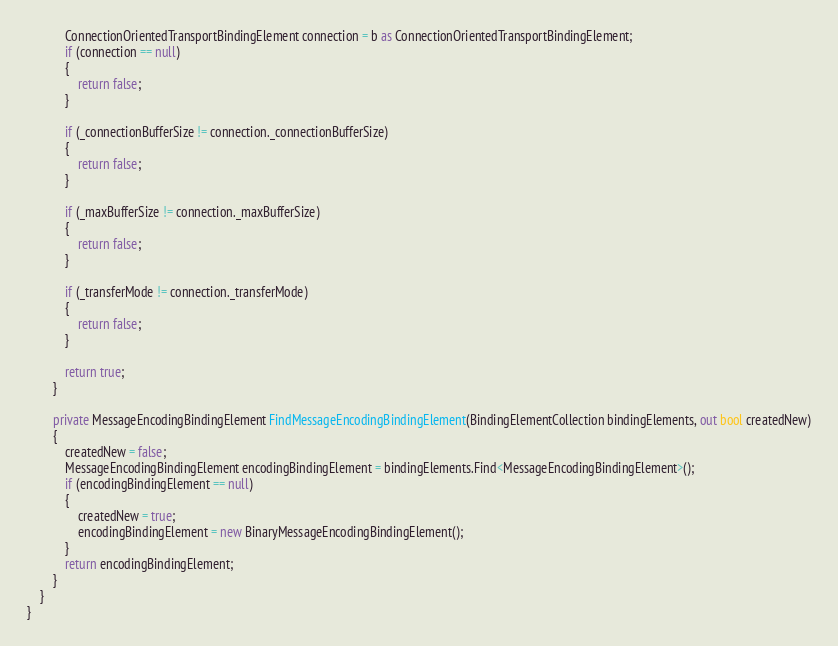<code> <loc_0><loc_0><loc_500><loc_500><_C#_>
            ConnectionOrientedTransportBindingElement connection = b as ConnectionOrientedTransportBindingElement;
            if (connection == null)
            {
                return false;
            }

            if (_connectionBufferSize != connection._connectionBufferSize)
            {
                return false;
            }

            if (_maxBufferSize != connection._maxBufferSize)
            {
                return false;
            }

            if (_transferMode != connection._transferMode)
            {
                return false;
            }

            return true;
        }

        private MessageEncodingBindingElement FindMessageEncodingBindingElement(BindingElementCollection bindingElements, out bool createdNew)
        {
            createdNew = false;
            MessageEncodingBindingElement encodingBindingElement = bindingElements.Find<MessageEncodingBindingElement>();
            if (encodingBindingElement == null)
            {
                createdNew = true;
                encodingBindingElement = new BinaryMessageEncodingBindingElement();
            }
            return encodingBindingElement;
        }
    }
}
</code> 